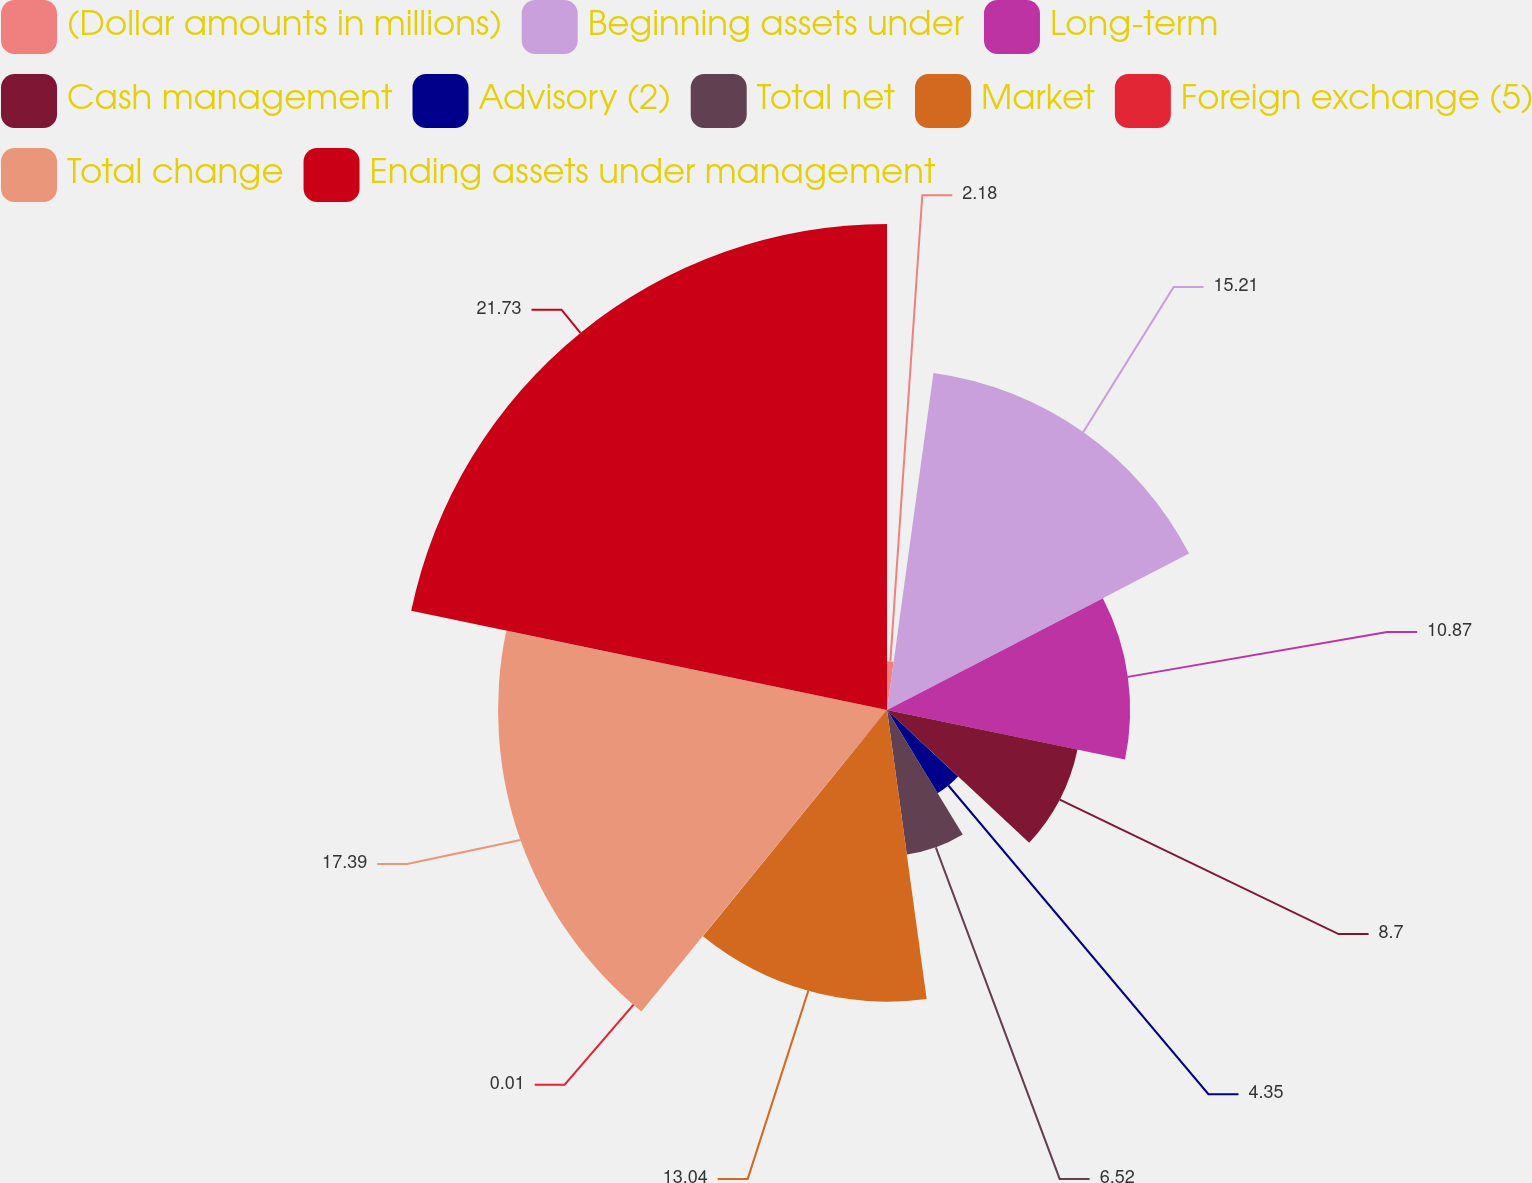<chart> <loc_0><loc_0><loc_500><loc_500><pie_chart><fcel>(Dollar amounts in millions)<fcel>Beginning assets under<fcel>Long-term<fcel>Cash management<fcel>Advisory (2)<fcel>Total net<fcel>Market<fcel>Foreign exchange (5)<fcel>Total change<fcel>Ending assets under management<nl><fcel>2.18%<fcel>15.21%<fcel>10.87%<fcel>8.7%<fcel>4.35%<fcel>6.52%<fcel>13.04%<fcel>0.01%<fcel>17.39%<fcel>21.73%<nl></chart> 